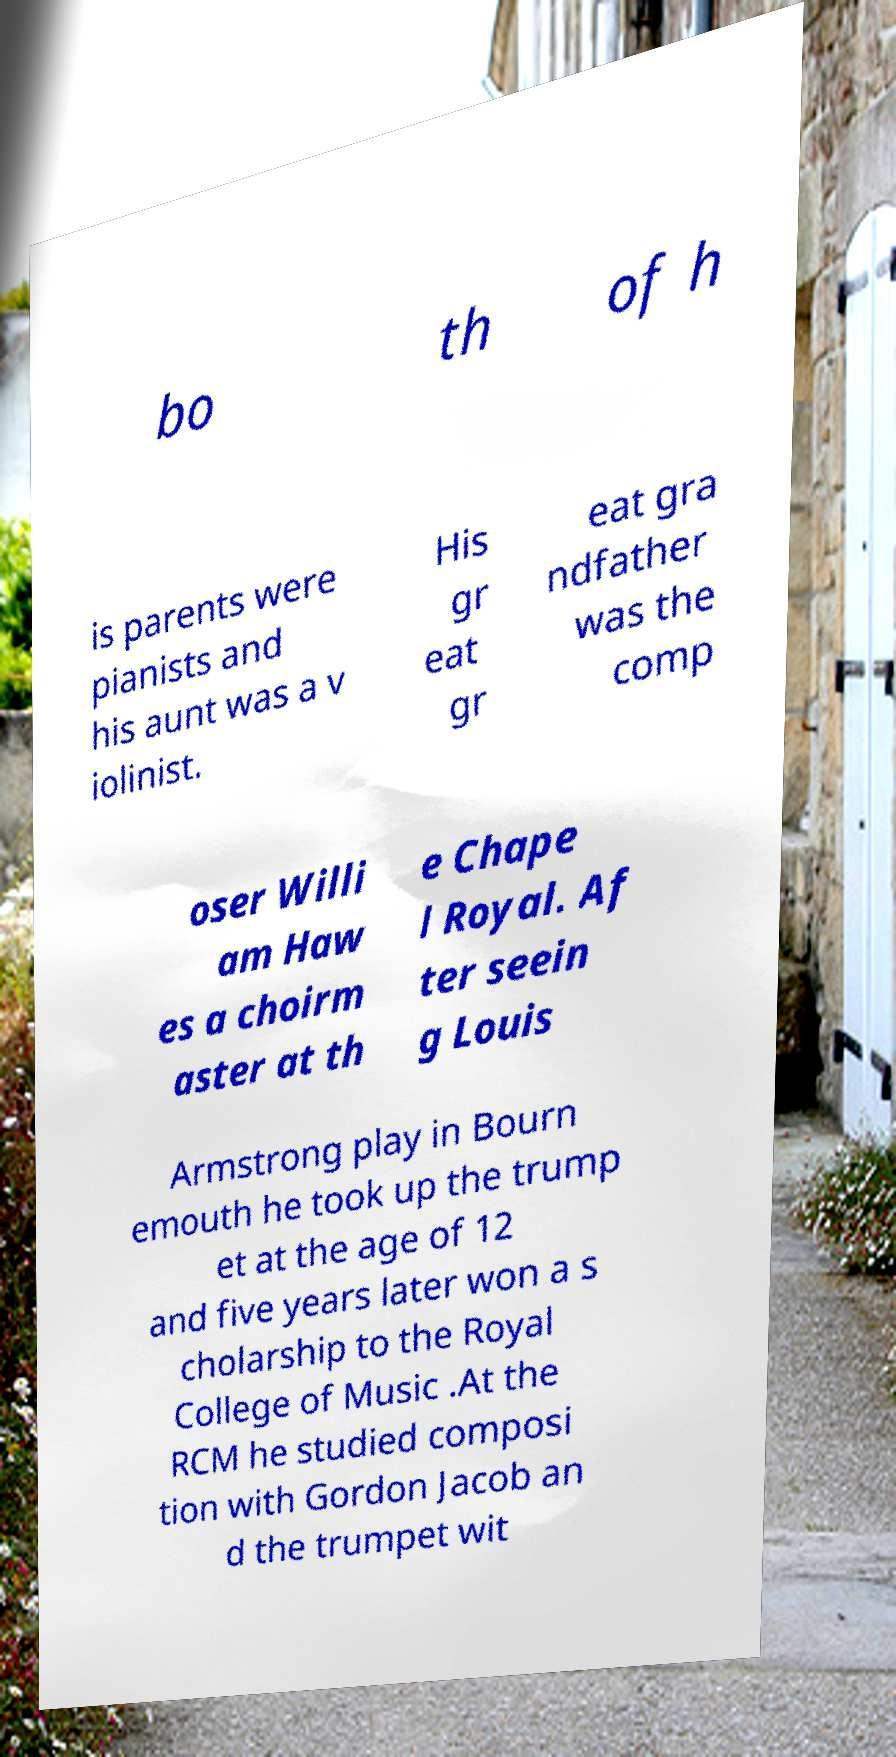Can you accurately transcribe the text from the provided image for me? bo th of h is parents were pianists and his aunt was a v iolinist. His gr eat gr eat gra ndfather was the comp oser Willi am Haw es a choirm aster at th e Chape l Royal. Af ter seein g Louis Armstrong play in Bourn emouth he took up the trump et at the age of 12 and five years later won a s cholarship to the Royal College of Music .At the RCM he studied composi tion with Gordon Jacob an d the trumpet wit 